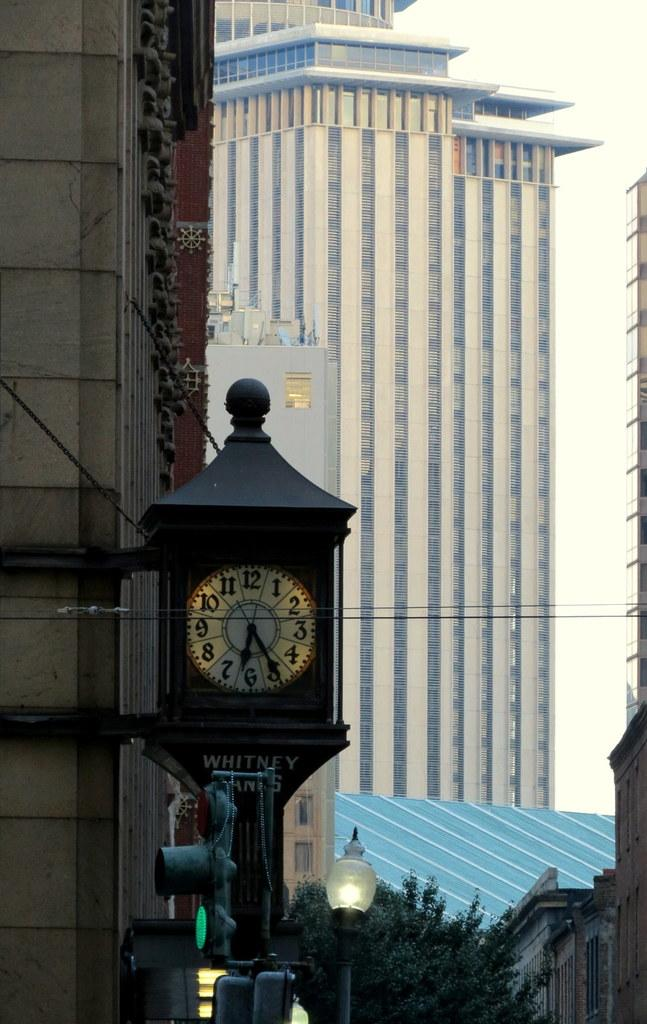<image>
Provide a brief description of the given image. The street tower clock in front of the Whitney Banks 